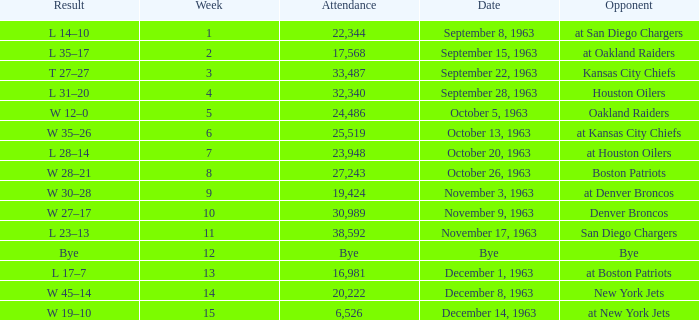Which Opponent has a Result of l 14–10? At san diego chargers. 